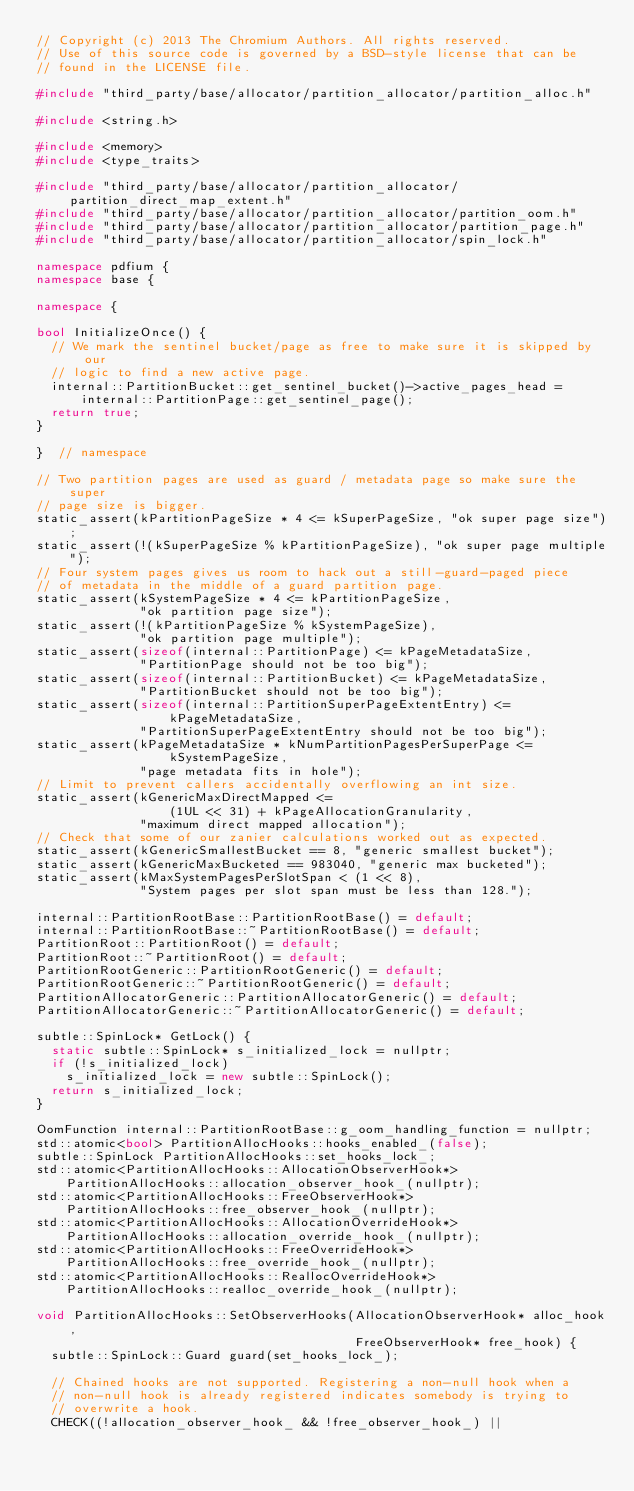<code> <loc_0><loc_0><loc_500><loc_500><_C++_>// Copyright (c) 2013 The Chromium Authors. All rights reserved.
// Use of this source code is governed by a BSD-style license that can be
// found in the LICENSE file.

#include "third_party/base/allocator/partition_allocator/partition_alloc.h"

#include <string.h>

#include <memory>
#include <type_traits>

#include "third_party/base/allocator/partition_allocator/partition_direct_map_extent.h"
#include "third_party/base/allocator/partition_allocator/partition_oom.h"
#include "third_party/base/allocator/partition_allocator/partition_page.h"
#include "third_party/base/allocator/partition_allocator/spin_lock.h"

namespace pdfium {
namespace base {

namespace {

bool InitializeOnce() {
  // We mark the sentinel bucket/page as free to make sure it is skipped by our
  // logic to find a new active page.
  internal::PartitionBucket::get_sentinel_bucket()->active_pages_head =
      internal::PartitionPage::get_sentinel_page();
  return true;
}

}  // namespace

// Two partition pages are used as guard / metadata page so make sure the super
// page size is bigger.
static_assert(kPartitionPageSize * 4 <= kSuperPageSize, "ok super page size");
static_assert(!(kSuperPageSize % kPartitionPageSize), "ok super page multiple");
// Four system pages gives us room to hack out a still-guard-paged piece
// of metadata in the middle of a guard partition page.
static_assert(kSystemPageSize * 4 <= kPartitionPageSize,
              "ok partition page size");
static_assert(!(kPartitionPageSize % kSystemPageSize),
              "ok partition page multiple");
static_assert(sizeof(internal::PartitionPage) <= kPageMetadataSize,
              "PartitionPage should not be too big");
static_assert(sizeof(internal::PartitionBucket) <= kPageMetadataSize,
              "PartitionBucket should not be too big");
static_assert(sizeof(internal::PartitionSuperPageExtentEntry) <=
                  kPageMetadataSize,
              "PartitionSuperPageExtentEntry should not be too big");
static_assert(kPageMetadataSize * kNumPartitionPagesPerSuperPage <=
                  kSystemPageSize,
              "page metadata fits in hole");
// Limit to prevent callers accidentally overflowing an int size.
static_assert(kGenericMaxDirectMapped <=
                  (1UL << 31) + kPageAllocationGranularity,
              "maximum direct mapped allocation");
// Check that some of our zanier calculations worked out as expected.
static_assert(kGenericSmallestBucket == 8, "generic smallest bucket");
static_assert(kGenericMaxBucketed == 983040, "generic max bucketed");
static_assert(kMaxSystemPagesPerSlotSpan < (1 << 8),
              "System pages per slot span must be less than 128.");

internal::PartitionRootBase::PartitionRootBase() = default;
internal::PartitionRootBase::~PartitionRootBase() = default;
PartitionRoot::PartitionRoot() = default;
PartitionRoot::~PartitionRoot() = default;
PartitionRootGeneric::PartitionRootGeneric() = default;
PartitionRootGeneric::~PartitionRootGeneric() = default;
PartitionAllocatorGeneric::PartitionAllocatorGeneric() = default;
PartitionAllocatorGeneric::~PartitionAllocatorGeneric() = default;

subtle::SpinLock* GetLock() {
  static subtle::SpinLock* s_initialized_lock = nullptr;
  if (!s_initialized_lock)
    s_initialized_lock = new subtle::SpinLock();
  return s_initialized_lock;
}

OomFunction internal::PartitionRootBase::g_oom_handling_function = nullptr;
std::atomic<bool> PartitionAllocHooks::hooks_enabled_(false);
subtle::SpinLock PartitionAllocHooks::set_hooks_lock_;
std::atomic<PartitionAllocHooks::AllocationObserverHook*>
    PartitionAllocHooks::allocation_observer_hook_(nullptr);
std::atomic<PartitionAllocHooks::FreeObserverHook*>
    PartitionAllocHooks::free_observer_hook_(nullptr);
std::atomic<PartitionAllocHooks::AllocationOverrideHook*>
    PartitionAllocHooks::allocation_override_hook_(nullptr);
std::atomic<PartitionAllocHooks::FreeOverrideHook*>
    PartitionAllocHooks::free_override_hook_(nullptr);
std::atomic<PartitionAllocHooks::ReallocOverrideHook*>
    PartitionAllocHooks::realloc_override_hook_(nullptr);

void PartitionAllocHooks::SetObserverHooks(AllocationObserverHook* alloc_hook,
                                           FreeObserverHook* free_hook) {
  subtle::SpinLock::Guard guard(set_hooks_lock_);

  // Chained hooks are not supported. Registering a non-null hook when a
  // non-null hook is already registered indicates somebody is trying to
  // overwrite a hook.
  CHECK((!allocation_observer_hook_ && !free_observer_hook_) ||</code> 